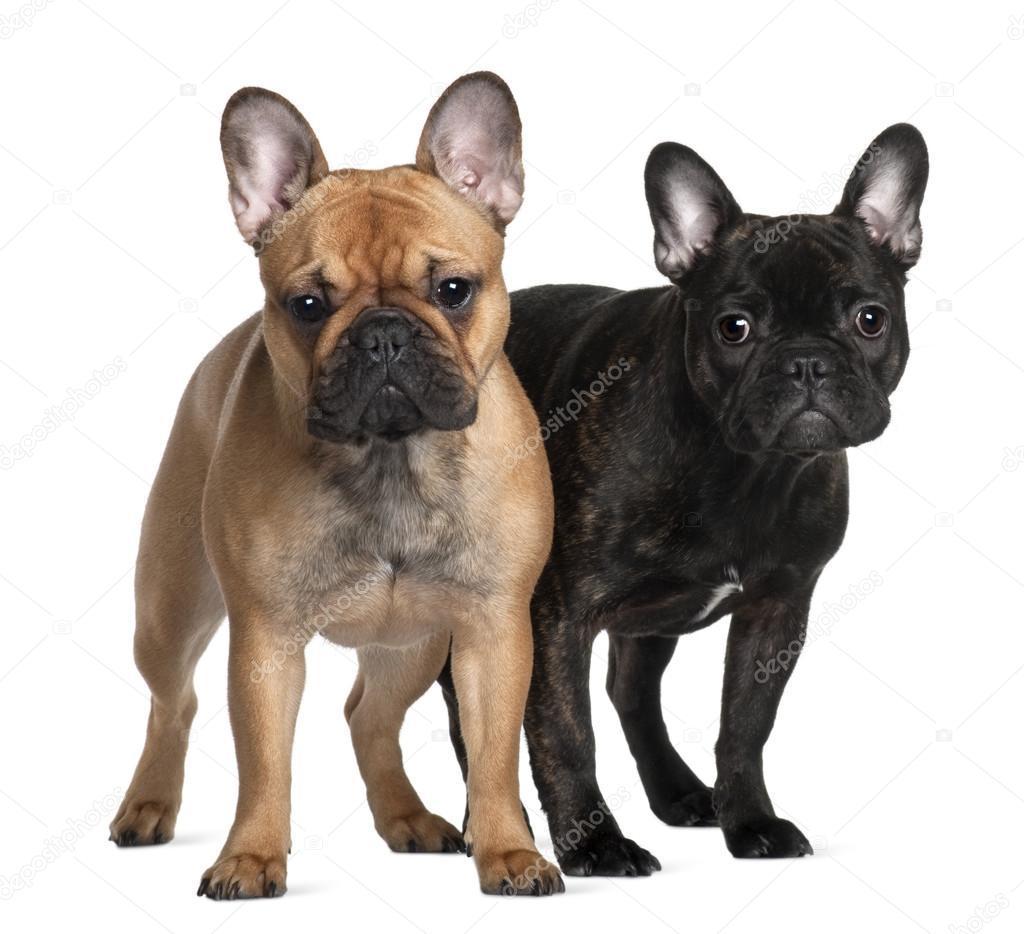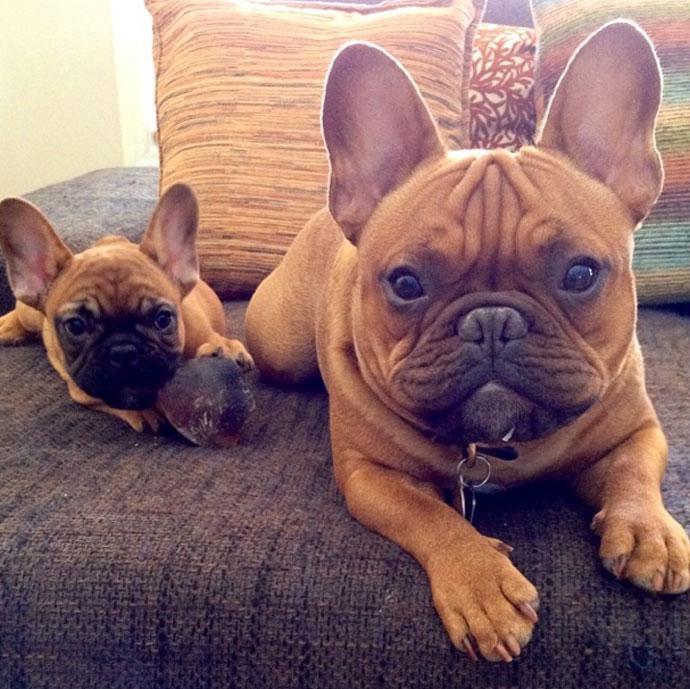The first image is the image on the left, the second image is the image on the right. Considering the images on both sides, is "There are two french bull dogs laying on a bed." valid? Answer yes or no. Yes. The first image is the image on the left, the second image is the image on the right. For the images displayed, is the sentence "An image shows two tan-colored dogs lounging on a cushioned item." factually correct? Answer yes or no. Yes. 